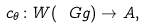Convert formula to latex. <formula><loc_0><loc_0><loc_500><loc_500>c _ { \theta } \colon W ( \ G g ) \to A ,</formula> 